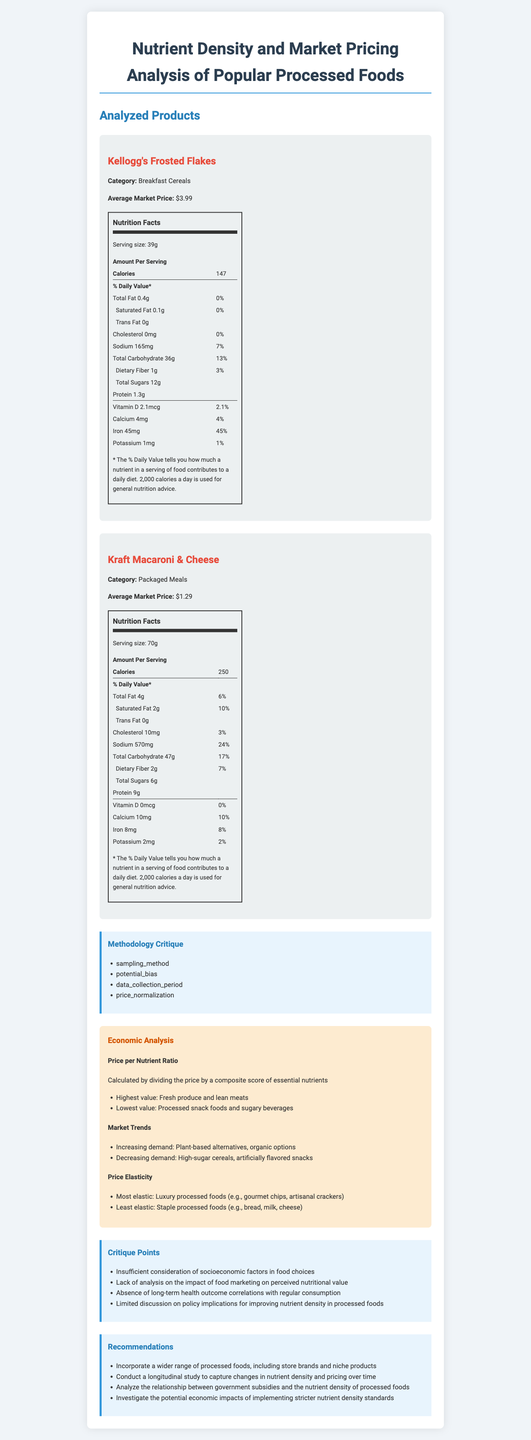what is the publication date of the study? The summary of the study provided in the document states that the publication date is 2023-05-15.
Answer: 2023-05-15 who was the lead researcher of the study? According to the study overview, the lead researcher was Dr. Emily Thornton.
Answer: Dr. Emily Thornton how many products were analyzed in the study? The document provides details for Kellogg's Frosted Flakes and Kraft Macaroni & Cheese, showing that two products were analyzed.
Answer: 2 which product has the higher sodium content per serving? A. Kellogg's Frosted Flakes B. Kraft Macaroni & Cheese Kellogg's Frosted Flakes has 165mg of sodium, while Kraft Macaroni & Cheese has 570mg of sodium.
Answer: B what critique points were mentioned regarding the study's methodology? The critique section lists these four points about the methodology.
Answer: Insufficient consideration of socioeconomic factors, lack of analysis on the impact of food marketing, absence of long-term health outcome correlations, limited discussion on policy implications what potential bias was identified in the sampling method? The critique section mentions that the sampling method may be biased due to the overrepresentation of urban food products.
Answer: Overrepresentation of urban food products what was the price normalization issue highlighted in the critique? The methodology critique points out that price normalization did not consider regional price differences.
Answer: Lack of consideration for regional price differences what is the price per nutrient ratio explanation provided in the economic analysis? The economic analysis section explains the price per nutrient ratio as being calculated by dividing the price by a composite score of essential nutrients.
Answer: Calculated by dividing the price by a composite score of essential nutrients which products had the highest and lowest price per nutrient ratio values? A. Fresh produce B. Lean meats C. Processed snack foods and sugary beverages The economic analysis states that the highest values were for fresh produce and lean meats, while the lowest values were for processed snack foods and sugary beverages.
Answer: Highest: A, B; Lowest: C what policy implications are suggested in the recommendations? One of the recommendations is to investigate the potential economic impacts of stricter nutrient density standards.
Answer: Investigate the economic impacts of implementing stricter nutrient density standards does the document provide a detailed analysis of seasonal variations in food pricing? The methodology critique section mentions that the 3-month data collection period was insufficient for capturing seasonal variations, indicating that such analysis was not provided.
Answer: No were long-term health outcomes of consuming the analyzed products discussed? The critique points note that there was an absence of long-term health outcome correlations with regular consumption of the analyzed products.
Answer: No summarize the main findings and suggestions of the document The document identifies nutrient density disparities in processed foods, critiques the research methodology, and provides policy and research recommendations to address the highlighted issues.
Answer: The study examined the nutrient density and market pricing of popular processed foods using a sample size of 500, with Dr. Emily Thornton leading the research. The analysis highlighted variances in price per nutrient ratios, identified market trends, and captured elasticity in pricing. Several methodological critiques were noted, including overrepresentation of urban products and inadequate seasonal data. The document recommends incorporating a wider range of products, conducting longitudinal studies, and investigating the impact of government subsidies and stricter nutrient density standards. did the study consider the impact of food marketing on perceived nutritional value? The critique section explicitly states that the study lacked analysis on the impact of food marketing on perceived nutritional value.
Answer: No why was the price normalization in the study potentially misleading? The critique section points out that the study did not account for regional price differences, potentially leading to misleading price normalization.
Answer: Because regional price differences were not considered 